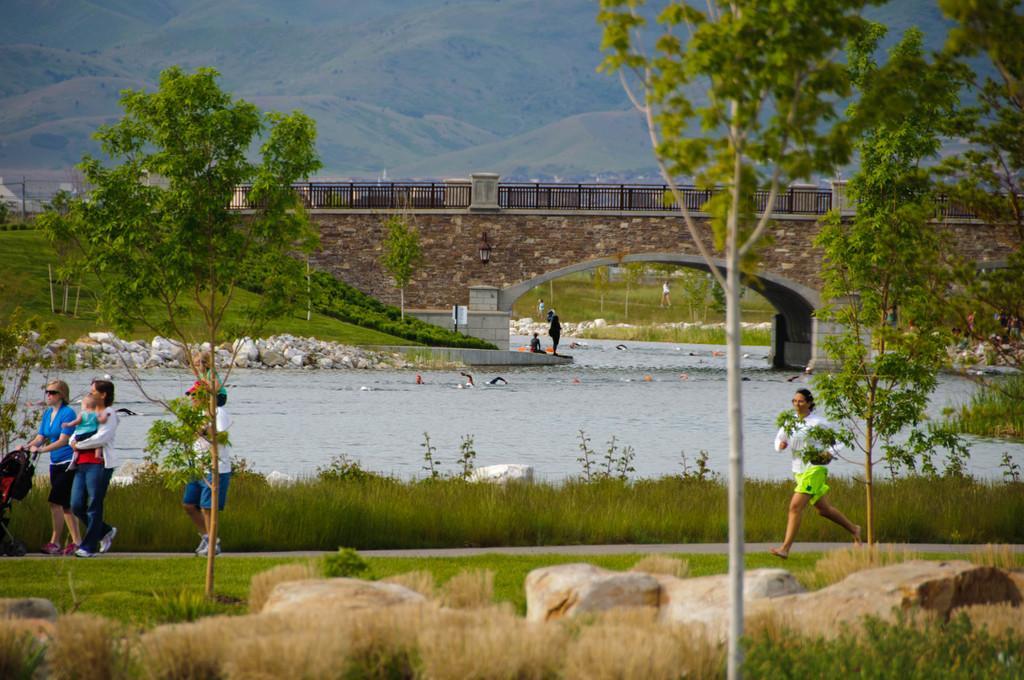Please provide a concise description of this image. In this image we can see a group of people. In that a woman is carrying a baby and a person is swimming in the water. We can also see some grass, plants, stones, trees, a board to a pole and a bridge with railing. On the backside we can see the hills. 